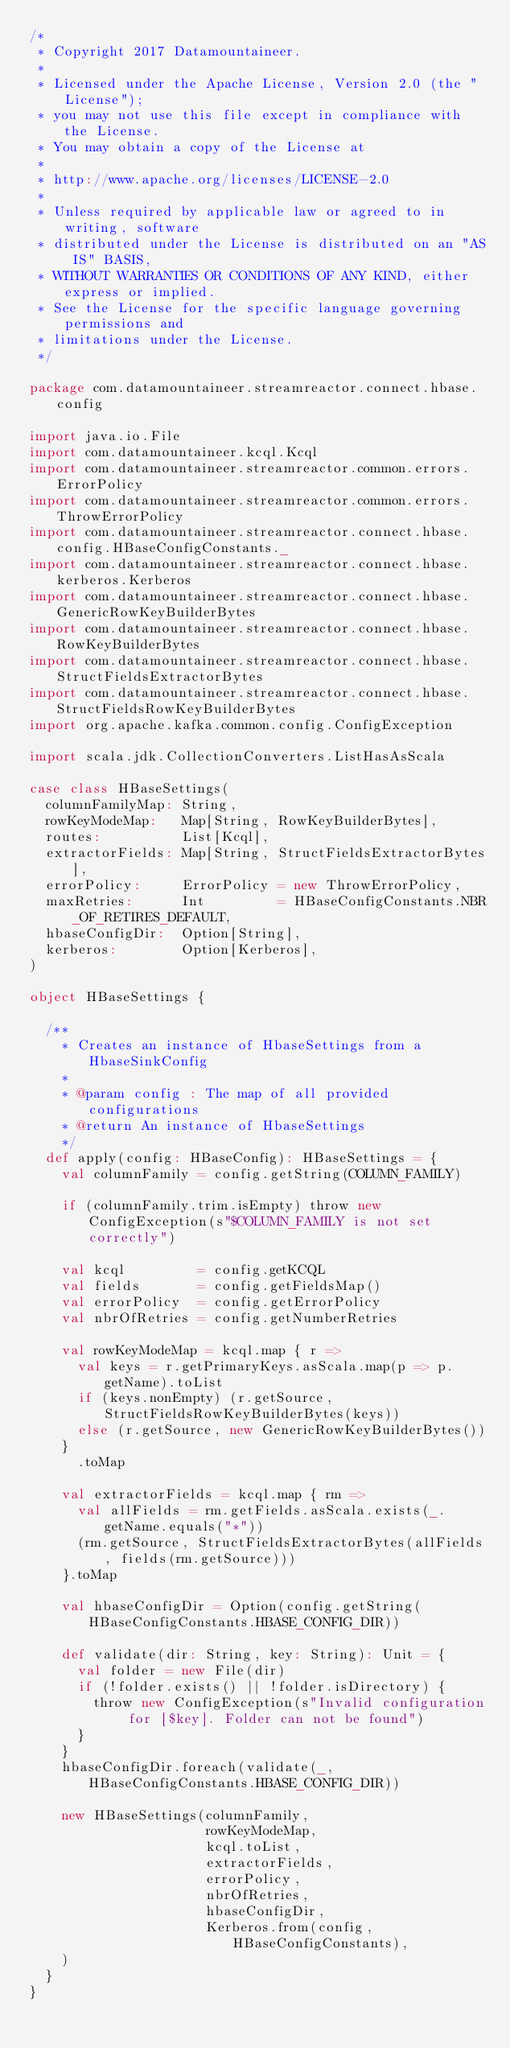Convert code to text. <code><loc_0><loc_0><loc_500><loc_500><_Scala_>/*
 * Copyright 2017 Datamountaineer.
 *
 * Licensed under the Apache License, Version 2.0 (the "License");
 * you may not use this file except in compliance with the License.
 * You may obtain a copy of the License at
 *
 * http://www.apache.org/licenses/LICENSE-2.0
 *
 * Unless required by applicable law or agreed to in writing, software
 * distributed under the License is distributed on an "AS IS" BASIS,
 * WITHOUT WARRANTIES OR CONDITIONS OF ANY KIND, either express or implied.
 * See the License for the specific language governing permissions and
 * limitations under the License.
 */

package com.datamountaineer.streamreactor.connect.hbase.config

import java.io.File
import com.datamountaineer.kcql.Kcql
import com.datamountaineer.streamreactor.common.errors.ErrorPolicy
import com.datamountaineer.streamreactor.common.errors.ThrowErrorPolicy
import com.datamountaineer.streamreactor.connect.hbase.config.HBaseConfigConstants._
import com.datamountaineer.streamreactor.connect.hbase.kerberos.Kerberos
import com.datamountaineer.streamreactor.connect.hbase.GenericRowKeyBuilderBytes
import com.datamountaineer.streamreactor.connect.hbase.RowKeyBuilderBytes
import com.datamountaineer.streamreactor.connect.hbase.StructFieldsExtractorBytes
import com.datamountaineer.streamreactor.connect.hbase.StructFieldsRowKeyBuilderBytes
import org.apache.kafka.common.config.ConfigException

import scala.jdk.CollectionConverters.ListHasAsScala

case class HBaseSettings(
  columnFamilyMap: String,
  rowKeyModeMap:   Map[String, RowKeyBuilderBytes],
  routes:          List[Kcql],
  extractorFields: Map[String, StructFieldsExtractorBytes],
  errorPolicy:     ErrorPolicy = new ThrowErrorPolicy,
  maxRetries:      Int         = HBaseConfigConstants.NBR_OF_RETIRES_DEFAULT,
  hbaseConfigDir:  Option[String],
  kerberos:        Option[Kerberos],
)

object HBaseSettings {

  /**
    * Creates an instance of HbaseSettings from a HbaseSinkConfig
    *
    * @param config : The map of all provided configurations
    * @return An instance of HbaseSettings
    */
  def apply(config: HBaseConfig): HBaseSettings = {
    val columnFamily = config.getString(COLUMN_FAMILY)

    if (columnFamily.trim.isEmpty) throw new ConfigException(s"$COLUMN_FAMILY is not set correctly")

    val kcql         = config.getKCQL
    val fields       = config.getFieldsMap()
    val errorPolicy  = config.getErrorPolicy
    val nbrOfRetries = config.getNumberRetries

    val rowKeyModeMap = kcql.map { r =>
      val keys = r.getPrimaryKeys.asScala.map(p => p.getName).toList
      if (keys.nonEmpty) (r.getSource, StructFieldsRowKeyBuilderBytes(keys))
      else (r.getSource, new GenericRowKeyBuilderBytes())
    }
      .toMap

    val extractorFields = kcql.map { rm =>
      val allFields = rm.getFields.asScala.exists(_.getName.equals("*"))
      (rm.getSource, StructFieldsExtractorBytes(allFields, fields(rm.getSource)))
    }.toMap

    val hbaseConfigDir = Option(config.getString(HBaseConfigConstants.HBASE_CONFIG_DIR))

    def validate(dir: String, key: String): Unit = {
      val folder = new File(dir)
      if (!folder.exists() || !folder.isDirectory) {
        throw new ConfigException(s"Invalid configuration for [$key]. Folder can not be found")
      }
    }
    hbaseConfigDir.foreach(validate(_, HBaseConfigConstants.HBASE_CONFIG_DIR))

    new HBaseSettings(columnFamily,
                      rowKeyModeMap,
                      kcql.toList,
                      extractorFields,
                      errorPolicy,
                      nbrOfRetries,
                      hbaseConfigDir,
                      Kerberos.from(config, HBaseConfigConstants),
    )
  }
}
</code> 